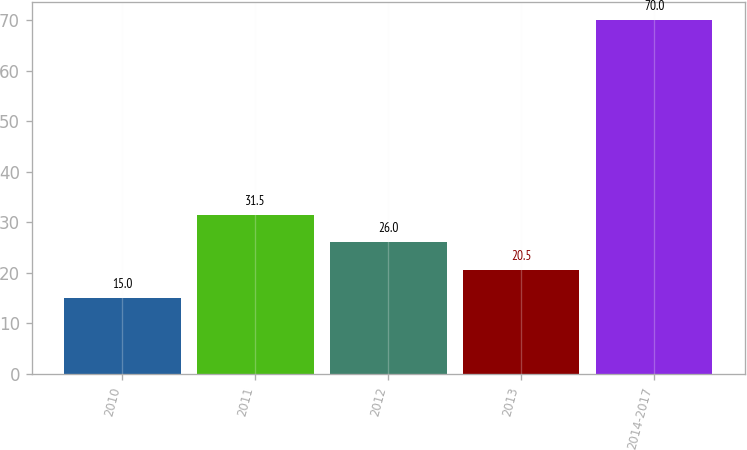Convert chart to OTSL. <chart><loc_0><loc_0><loc_500><loc_500><bar_chart><fcel>2010<fcel>2011<fcel>2012<fcel>2013<fcel>2014-2017<nl><fcel>15<fcel>31.5<fcel>26<fcel>20.5<fcel>70<nl></chart> 